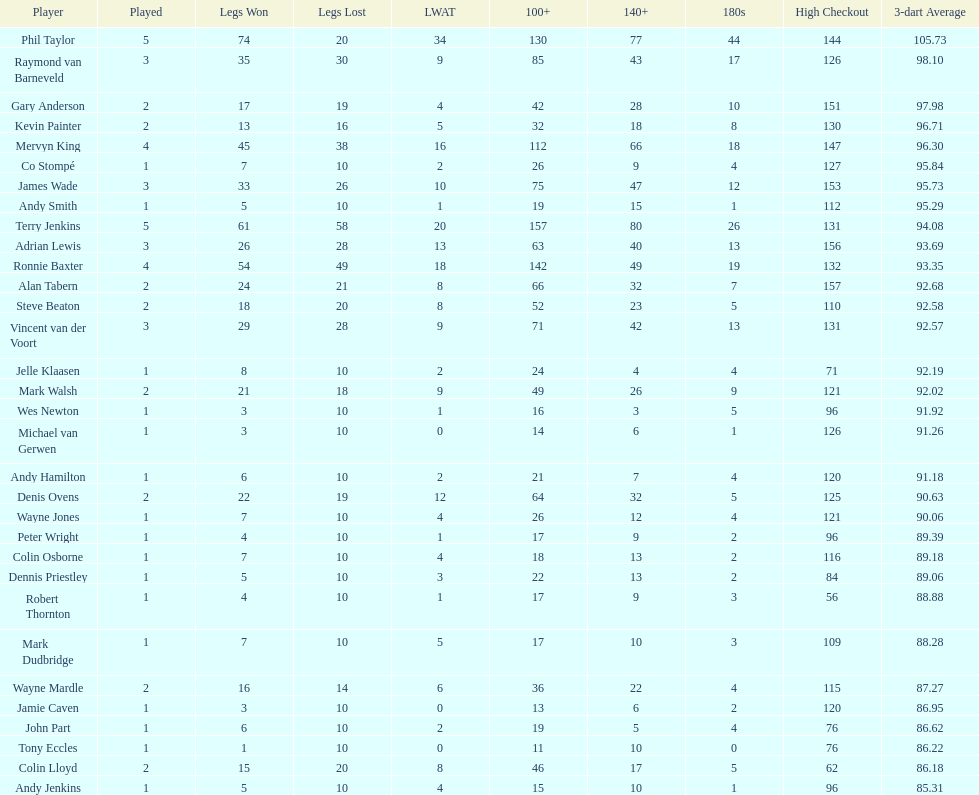How many players have a 3 dart average of more than 97? 3. 